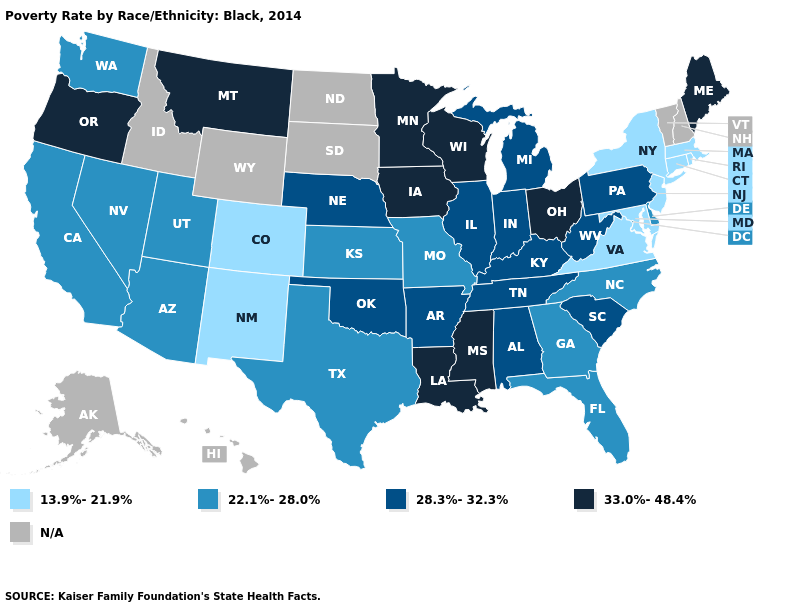Name the states that have a value in the range N/A?
Short answer required. Alaska, Hawaii, Idaho, New Hampshire, North Dakota, South Dakota, Vermont, Wyoming. Does the map have missing data?
Concise answer only. Yes. Name the states that have a value in the range N/A?
Keep it brief. Alaska, Hawaii, Idaho, New Hampshire, North Dakota, South Dakota, Vermont, Wyoming. What is the value of Minnesota?
Quick response, please. 33.0%-48.4%. Among the states that border West Virginia , which have the lowest value?
Short answer required. Maryland, Virginia. Name the states that have a value in the range 22.1%-28.0%?
Quick response, please. Arizona, California, Delaware, Florida, Georgia, Kansas, Missouri, Nevada, North Carolina, Texas, Utah, Washington. Among the states that border Alabama , does Florida have the highest value?
Be succinct. No. What is the value of Iowa?
Be succinct. 33.0%-48.4%. What is the value of Arkansas?
Quick response, please. 28.3%-32.3%. Name the states that have a value in the range 22.1%-28.0%?
Be succinct. Arizona, California, Delaware, Florida, Georgia, Kansas, Missouri, Nevada, North Carolina, Texas, Utah, Washington. What is the value of Kansas?
Short answer required. 22.1%-28.0%. How many symbols are there in the legend?
Give a very brief answer. 5. Name the states that have a value in the range N/A?
Give a very brief answer. Alaska, Hawaii, Idaho, New Hampshire, North Dakota, South Dakota, Vermont, Wyoming. Among the states that border Minnesota , which have the lowest value?
Concise answer only. Iowa, Wisconsin. 